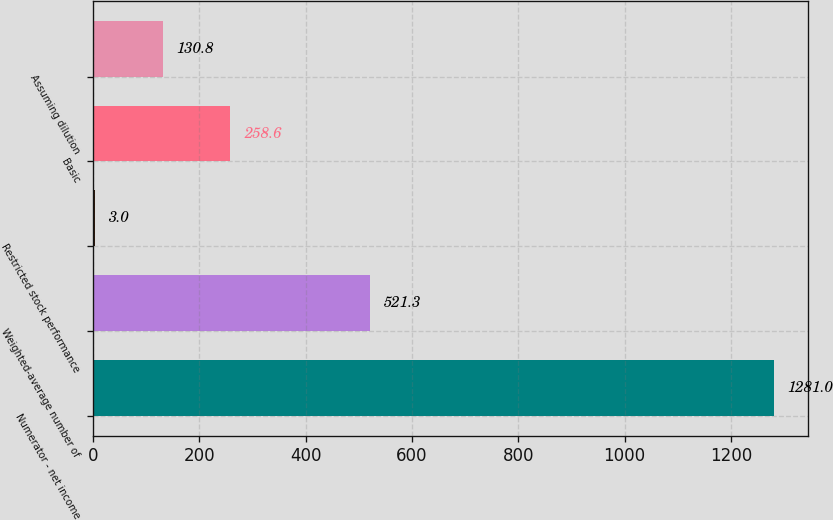Convert chart to OTSL. <chart><loc_0><loc_0><loc_500><loc_500><bar_chart><fcel>Numerator - net income<fcel>Weighted-average number of<fcel>Restricted stock performance<fcel>Basic<fcel>Assuming dilution<nl><fcel>1281<fcel>521.3<fcel>3<fcel>258.6<fcel>130.8<nl></chart> 